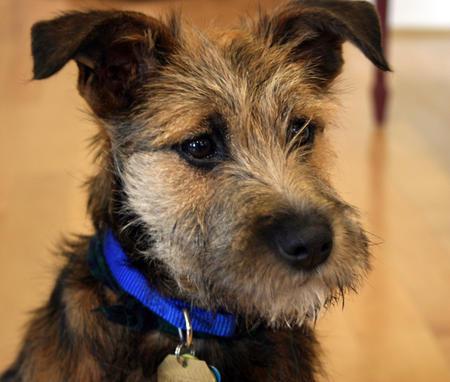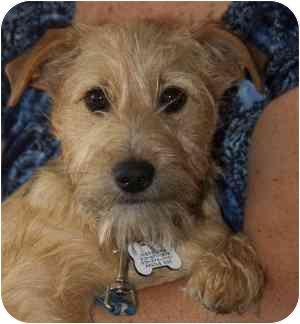The first image is the image on the left, the second image is the image on the right. For the images shown, is this caption "A dog is shown in profile standing on green grass in at least one image." true? Answer yes or no. No. The first image is the image on the left, the second image is the image on the right. Considering the images on both sides, is "One dog is wearing a harness." valid? Answer yes or no. No. 